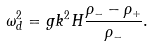<formula> <loc_0><loc_0><loc_500><loc_500>\omega ^ { 2 } _ { d } = g k ^ { 2 } H \frac { \rho _ { - } - \rho _ { + } } { \rho _ { - } } .</formula> 